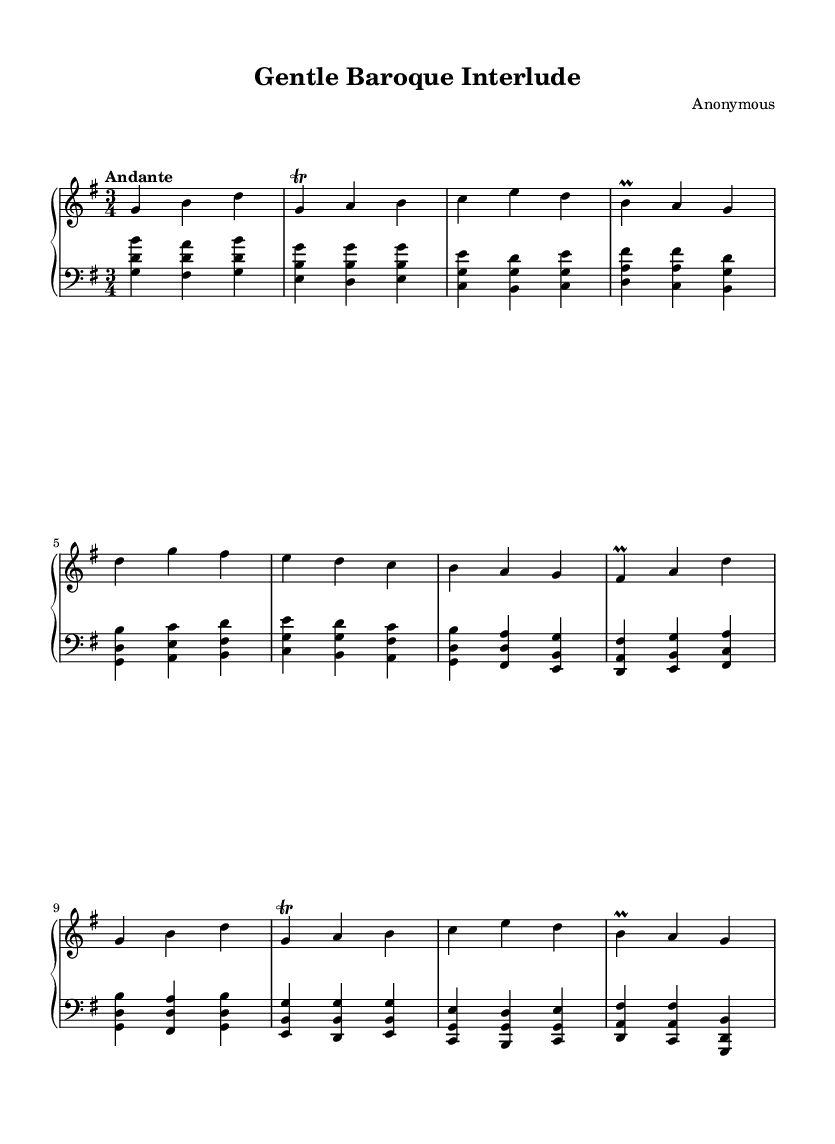What is the key signature of this music? The key signature shown in the music indicates G major, which has one sharp (F sharp).
Answer: G major What is the time signature of this piece? The time signature is indicated at the beginning of the score and shows 3/4, meaning there are three beats per measure and the quarter note gets one beat.
Answer: 3/4 What is the tempo marking for this composition? The tempo marking at the beginning states "Andante," which indicates a moderate pace, typically around 76-108 beats per minute.
Answer: Andante How many sections are in this piece? The structure of the music includes an A section, B section, and a return to an A section (A'), totaling three sections.
Answer: Three What is the dynamic marking of the A section? The sheet music does not specify explicit dynamics, but generally, Baroque music like this is often played at a mezzo-piano to mezzo-forte dynamic.
Answer: Mezzo-piano What technique is used in the right-hand part with the trill? The right-hand part contains a trill marking, which indicates a rapid alternation between the written note (A) and the note above it (B). This is a common ornamentation technique in Baroque music.
Answer: Trill What is the general mood intended for this composition? The gentle character of the melodic lines and the flowing rhythm suggest a calm and peaceful ambiance, which is typical for office background music.
Answer: Calm 